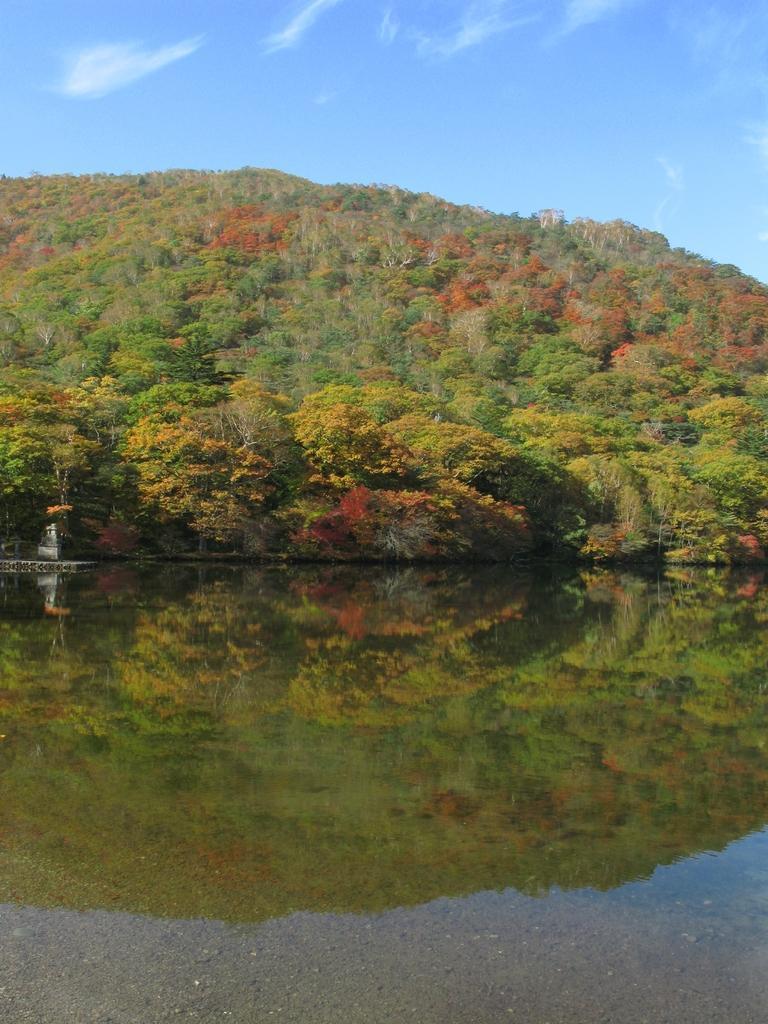In one or two sentences, can you explain what this image depicts? In this picture we can see an object, water, trees, mountain and in the background we can see the sky. 